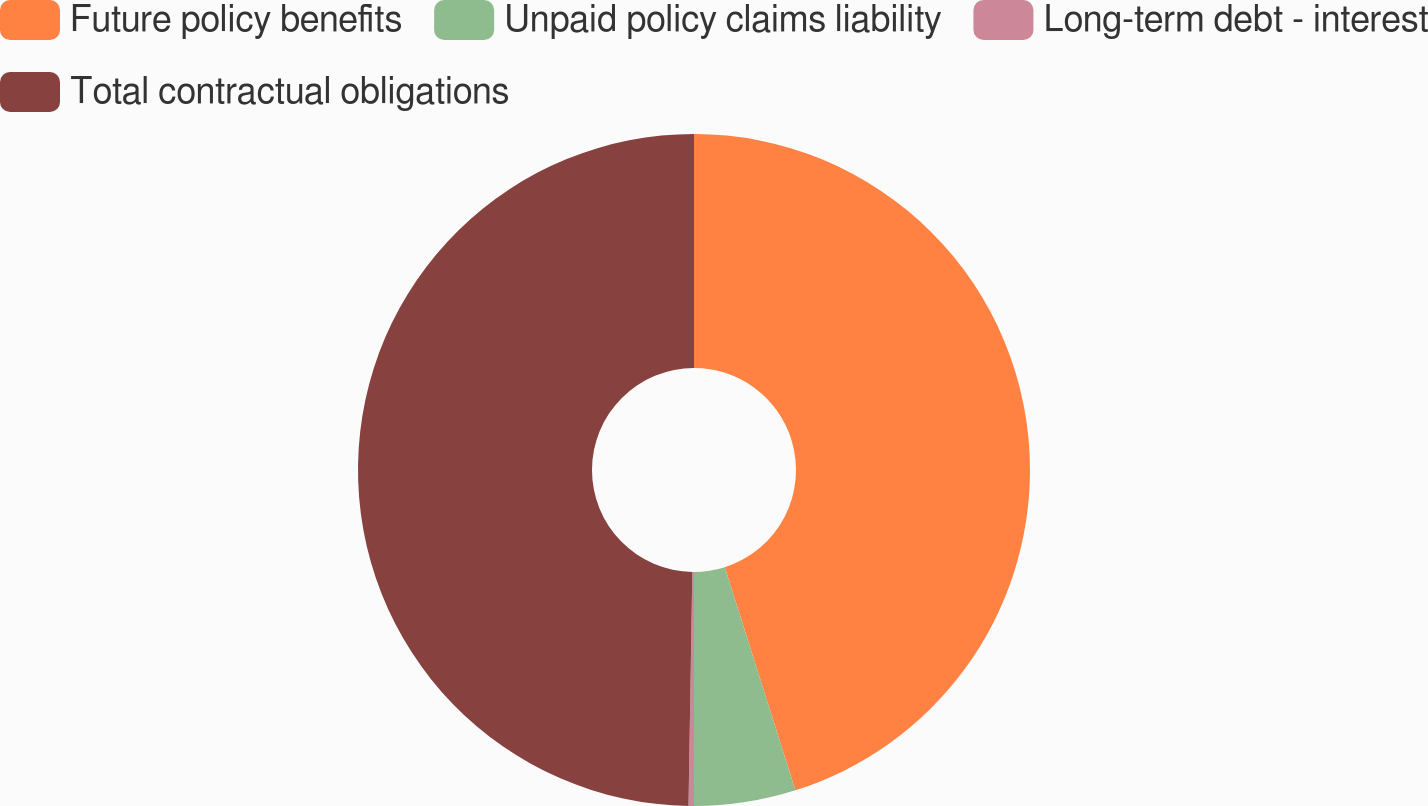Convert chart to OTSL. <chart><loc_0><loc_0><loc_500><loc_500><pie_chart><fcel>Future policy benefits<fcel>Unpaid policy claims liability<fcel>Long-term debt - interest<fcel>Total contractual obligations<nl><fcel>45.12%<fcel>4.88%<fcel>0.26%<fcel>49.74%<nl></chart> 